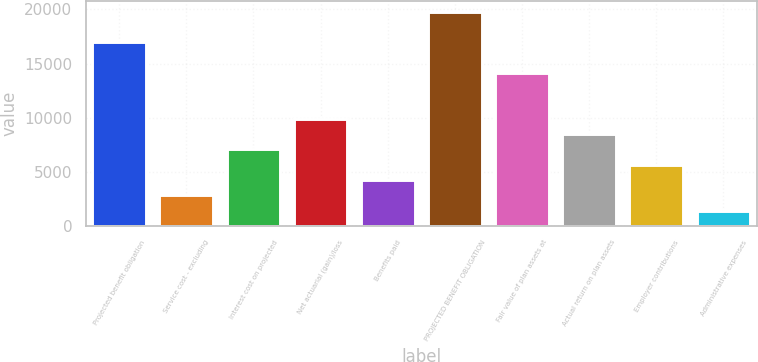<chart> <loc_0><loc_0><loc_500><loc_500><bar_chart><fcel>Projected benefit obligation<fcel>Service cost - excluding<fcel>Interest cost on projected<fcel>Net actuarial (gain)/loss<fcel>Benefits paid<fcel>PROJECTED BENEFIT OBLIGATION<fcel>Fair value of plan assets at<fcel>Actual return on plan assets<fcel>Employer contributions<fcel>Administrative expenses<nl><fcel>16963.6<fcel>2830.6<fcel>7070.5<fcel>9897.1<fcel>4243.9<fcel>19790.2<fcel>14137<fcel>8483.8<fcel>5657.2<fcel>1417.3<nl></chart> 